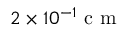<formula> <loc_0><loc_0><loc_500><loc_500>2 \times 1 0 ^ { - 1 } c m</formula> 